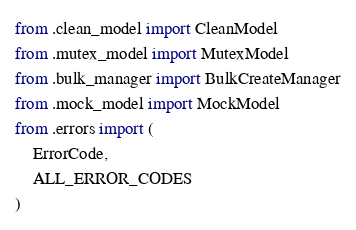Convert code to text. <code><loc_0><loc_0><loc_500><loc_500><_Python_>from .clean_model import CleanModel
from .mutex_model import MutexModel
from .bulk_manager import BulkCreateManager
from .mock_model import MockModel
from .errors import (
    ErrorCode,
    ALL_ERROR_CODES
)
</code> 